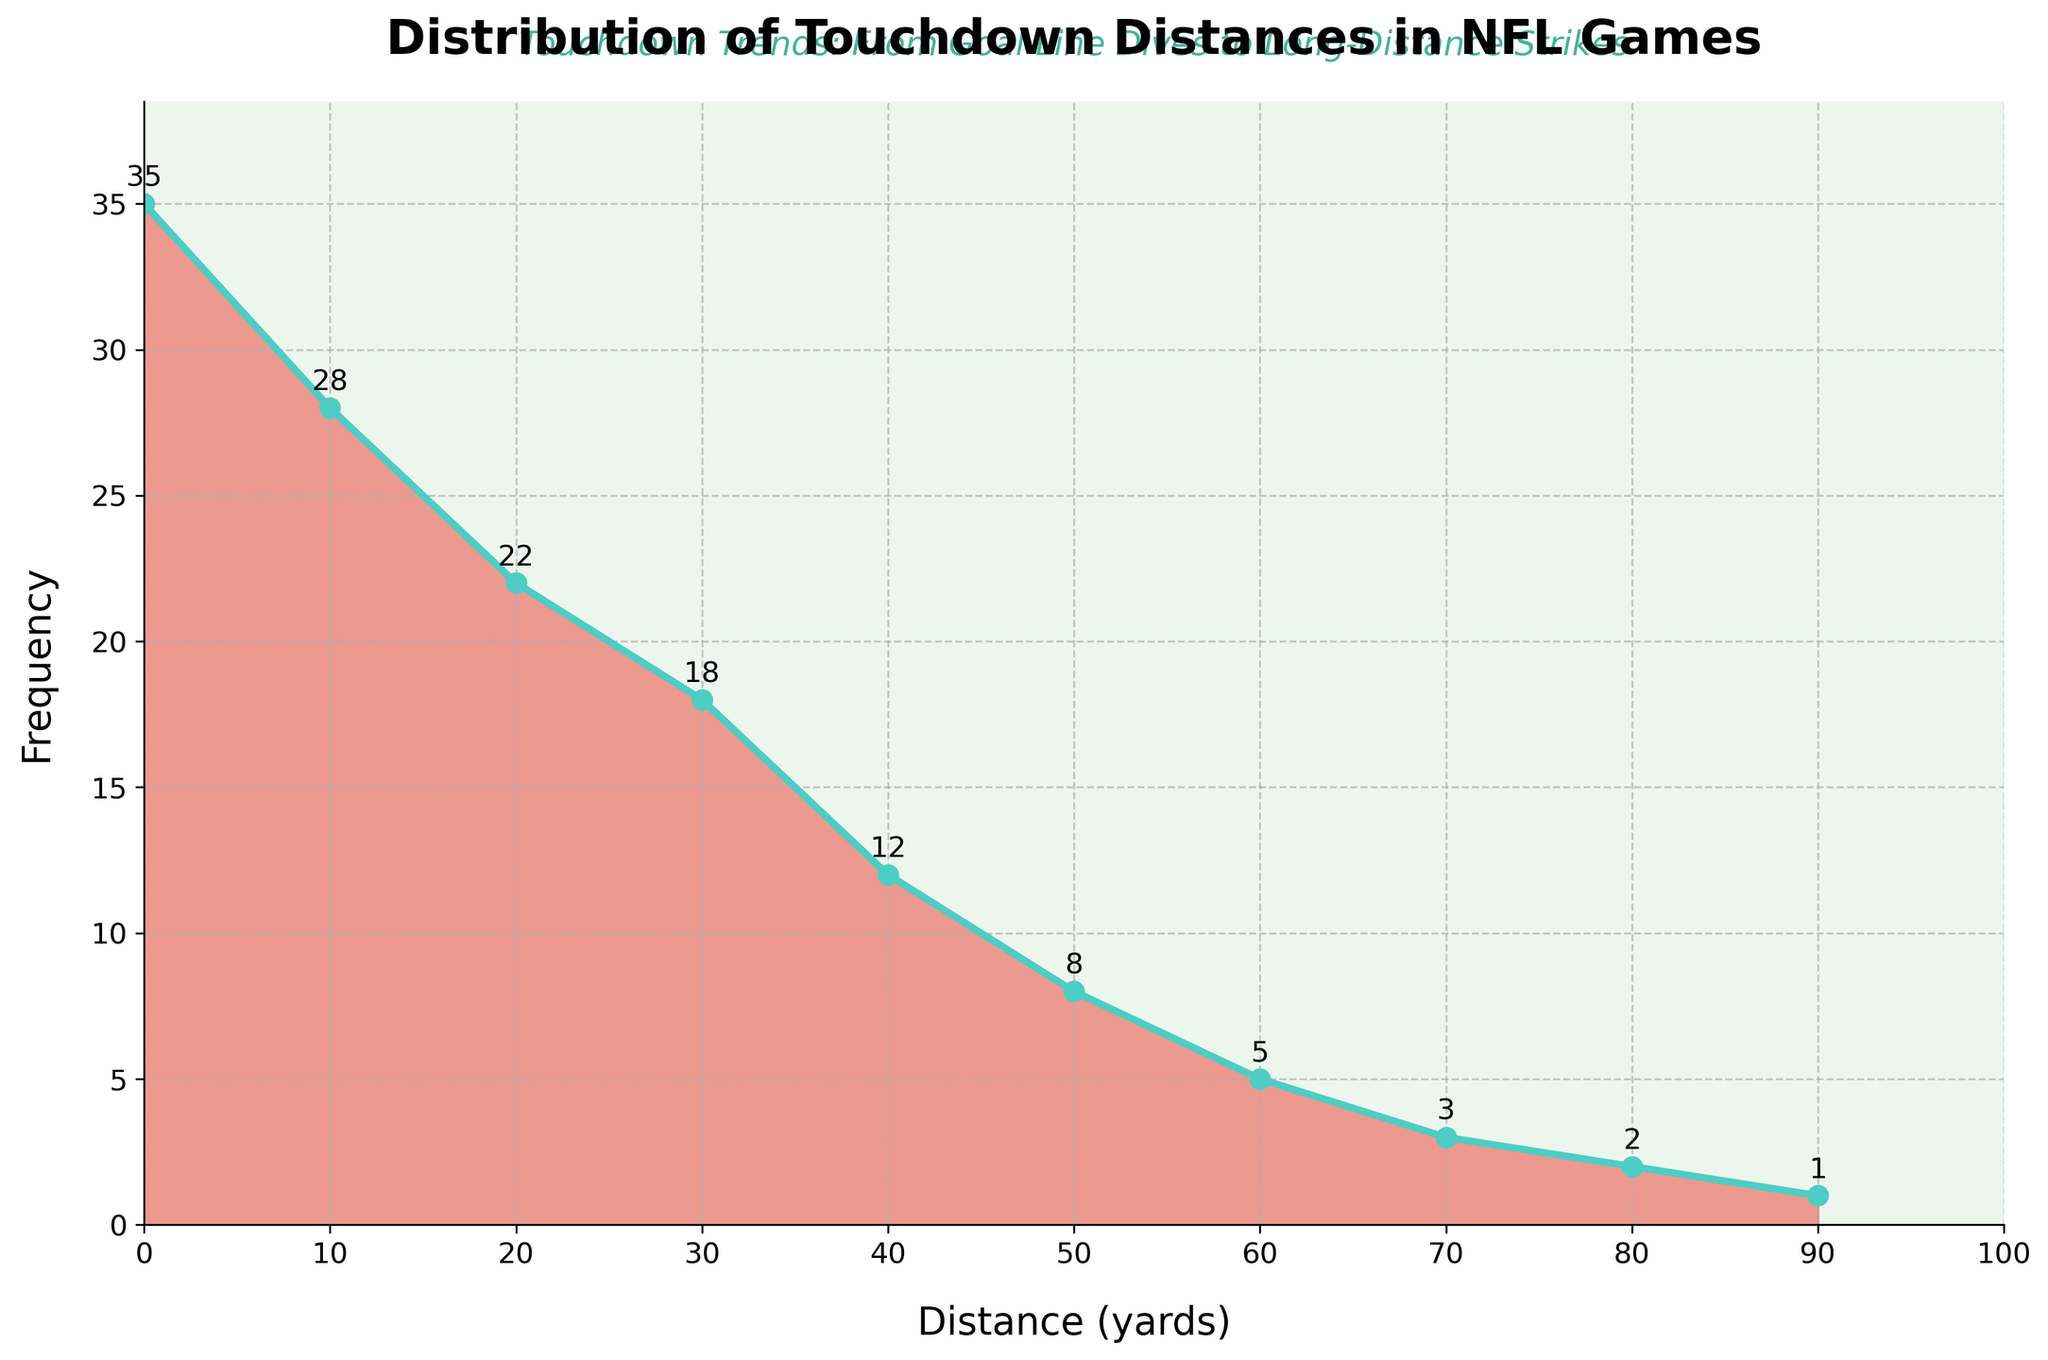What is the title of the plot? The title of the plot is displayed at the top and reads "Distribution of Touchdown Distances in NFL Games"
Answer: Distribution of Touchdown Distances in NFL Games What does the x-axis represent? The x-axis is labeled "Distance (yards)" and represents the distance in yards at which touchdowns were scored
Answer: Distance (yards) What distance range has the highest frequency of touchdowns? The plot shows the highest peak at the range 0-9 yards with a frequency of 35 touchdowns
Answer: 0-9 yards Which distance range has the lowest frequency of touchdowns? By observing the plot, the range 90-99 yards has the lowest frequency with only 1 touchdown
Answer: 90-99 yards What are the colors of the filled area and the line plot? The filled area is shaded in a color similar to light red, while the line plot is in a color similar to teal
Answer: light red (filled area) and teal (line plot) How many distance ranges have touchdown frequencies greater than 20? The range 0-9 yards and 10-19 yards have frequencies greater than 20, which makes it a total of 2 ranges
Answer: 2 What is the frequency of touchdowns for distances between 40-49 yards? The specific point for the range 40-49 yards shows a frequency of 12 touchdowns as annotated on the plot
Answer: 12 Compare the frequency of touchdowns between 20-29 yards and 50-59 yards. Which has more? The 20-29 yards range has a higher frequency (22 touchdowns) than the 50-59 yards range (8 touchdowns)
Answer: 20-29 yards has more What is the frequency difference between 20-29 yards and 30-39 yards? The frequency at 20-29 yards is 22 and at 30-39 yards is 18. The difference is calculated as 22 - 18 = 4
Answer: 4 Identify the frequency trend as the distance increases from 0 to 50 yards. Observing the plot, the frequency generally decreases as the distance increases from 0 to 50 yards
Answer: Frequency decreases 